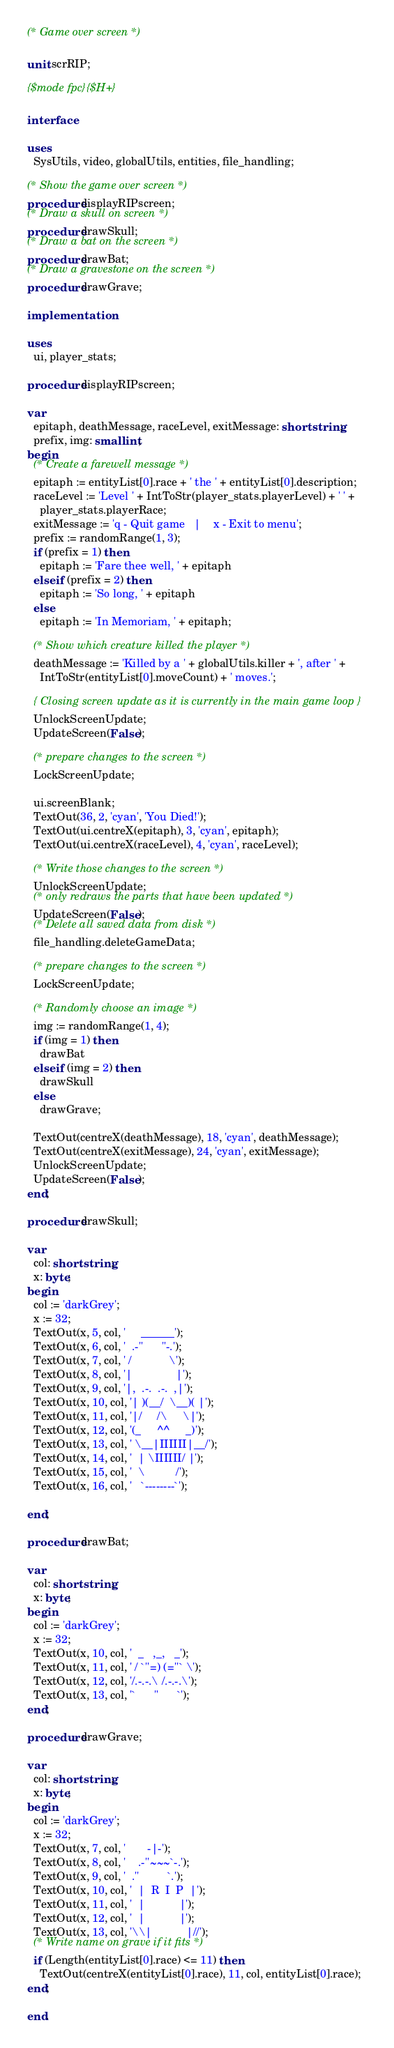Convert code to text. <code><loc_0><loc_0><loc_500><loc_500><_Pascal_>(* Game over screen *)

unit scrRIP;

{$mode fpc}{$H+}

interface

uses
  SysUtils, video, globalUtils, entities, file_handling;

(* Show the game over screen *)
procedure displayRIPscreen;
(* Draw a skull on screen *)
procedure drawSkull;
(* Draw a bat on the screen *)
procedure drawBat;
(* Draw a gravestone on the screen *)
procedure drawGrave;

implementation

uses
  ui, player_stats;

procedure displayRIPscreen;

var
  epitaph, deathMessage, raceLevel, exitMessage: shortstring;
  prefix, img: smallint;
begin
  (* Create a farewell message *)
  epitaph := entityList[0].race + ' the ' + entityList[0].description;
  raceLevel := 'Level ' + IntToStr(player_stats.playerLevel) + ' ' +
    player_stats.playerRace;
  exitMessage := 'q - Quit game   |    x - Exit to menu';
  prefix := randomRange(1, 3);
  if (prefix = 1) then
    epitaph := 'Fare thee well, ' + epitaph
  else if (prefix = 2) then
    epitaph := 'So long, ' + epitaph
  else
    epitaph := 'In Memoriam, ' + epitaph;

  (* Show which creature killed the player *)
  deathMessage := 'Killed by a ' + globalUtils.killer + ', after ' +
    IntToStr(entityList[0].moveCount) + ' moves.';

  { Closing screen update as it is currently in the main game loop }
  UnlockScreenUpdate;
  UpdateScreen(False);

  (* prepare changes to the screen *)
  LockScreenUpdate;

  ui.screenBlank;
  TextOut(36, 2, 'cyan', 'You Died!');
  TextOut(ui.centreX(epitaph), 3, 'cyan', epitaph);
  TextOut(ui.centreX(raceLevel), 4, 'cyan', raceLevel);

  (* Write those changes to the screen *)
  UnlockScreenUpdate;
  (* only redraws the parts that have been updated *)
  UpdateScreen(False);
  (* Delete all saved data from disk *)
  file_handling.deleteGameData;

  (* prepare changes to the screen *)
  LockScreenUpdate;

  (* Randomly choose an image *)
  img := randomRange(1, 4);
  if (img = 1) then
    drawBat
  else if (img = 2) then
    drawSkull
  else
    drawGrave;

  TextOut(centreX(deathMessage), 18, 'cyan', deathMessage);
  TextOut(centreX(exitMessage), 24, 'cyan', exitMessage);
  UnlockScreenUpdate;
  UpdateScreen(False);
end;

procedure drawSkull;

var
  col: shortstring;
  x: byte;
begin
  col := 'darkGrey';
  x := 32;
  TextOut(x, 5, col, '     ______');
  TextOut(x, 6, col, '  .-"      "-.');
  TextOut(x, 7, col, ' /            \');
  TextOut(x, 8, col, '|              |');
  TextOut(x, 9, col, '|,  .-.  .-.  ,|');
  TextOut(x, 10, col, '| )(__/  \__)( |');
  TextOut(x, 11, col, '|/     /\     \|');
  TextOut(x, 12, col, '(_     ^^     _)');
  TextOut(x, 13, col, ' \__|IIIIII|__/');
  TextOut(x, 14, col, '  | \IIIIII/ |');
  TextOut(x, 15, col, '  \          /');
  TextOut(x, 16, col, '   `--------`');

end;

procedure drawBat;

var
  col: shortstring;
  x: byte;
begin
  col := 'darkGrey';
  x := 32;
  TextOut(x, 10, col, '  _   ,_,   _');
  TextOut(x, 11, col, ' / `''=) (=''` \');
  TextOut(x, 12, col, '/.-.-.\ /.-.-.\');
  TextOut(x, 13, col, '`      "      `');
end;

procedure drawGrave;

var
  col: shortstring;
  x: byte;
begin
  col := 'darkGrey';
  x := 32;
  TextOut(x, 7, col, '       -|-');
  TextOut(x, 8, col, '    .-''~~~`-.');
  TextOut(x, 9, col, '  .''         `.');
  TextOut(x, 10, col, '  |  R  I  P  |');
  TextOut(x, 11, col, '  |           |');
  TextOut(x, 12, col, '  |           |');
  TextOut(x, 13, col, '\\|           |//');
  (* Write name on grave if it fits *)
  if (Length(entityList[0].race) <= 11) then
    TextOut(centreX(entityList[0].race), 11, col, entityList[0].race);
end;

end.
</code> 